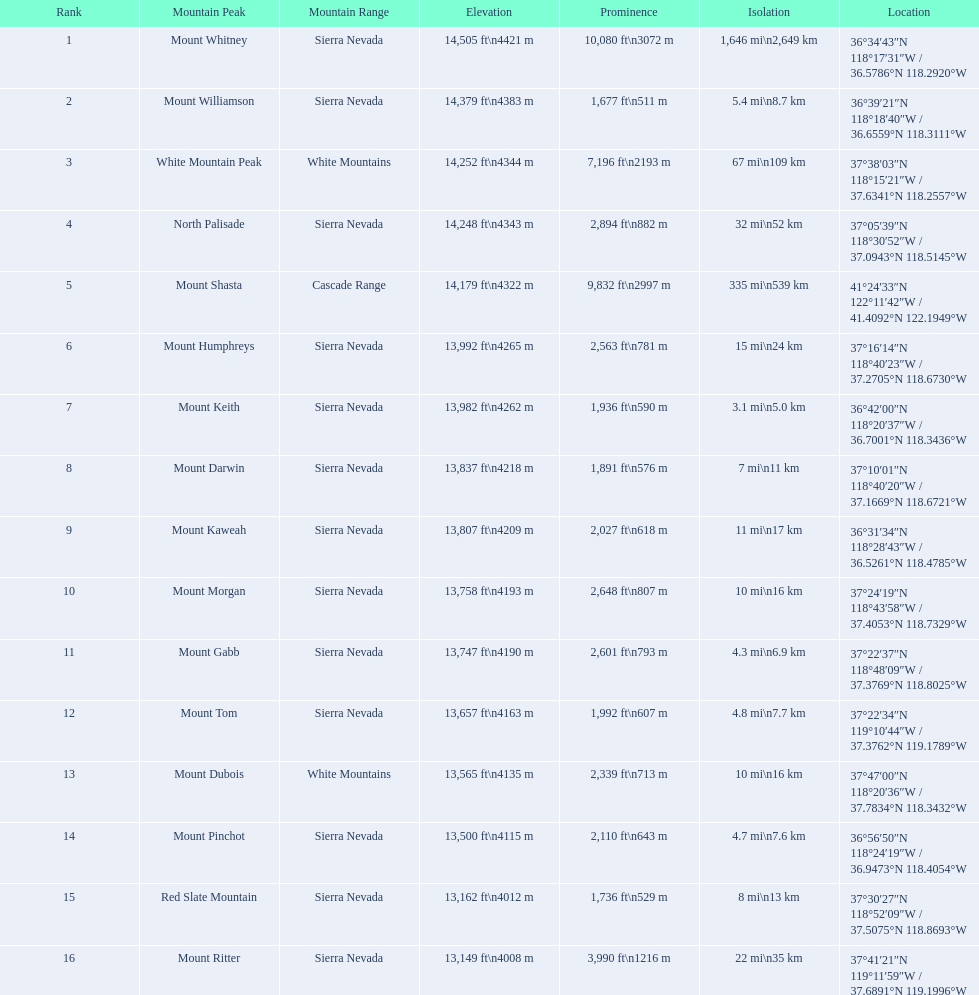What are the mentioned heights? 14,505 ft\n4421 m, 14,379 ft\n4383 m, 14,252 ft\n4344 m, 14,248 ft\n4343 m, 14,179 ft\n4322 m, 13,992 ft\n4265 m, 13,982 ft\n4262 m, 13,837 ft\n4218 m, 13,807 ft\n4209 m, 13,758 ft\n4193 m, 13,747 ft\n4190 m, 13,657 ft\n4163 m, 13,565 ft\n4135 m, 13,500 ft\n4115 m, 13,162 ft\n4012 m, 13,149 ft\n4008 m. Which of them is 13,149 ft or lower? 13,149 ft\n4008 m. To which mountain summit does this figure relate? Mount Ritter. 